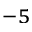Convert formula to latex. <formula><loc_0><loc_0><loc_500><loc_500>^ { - 5 }</formula> 